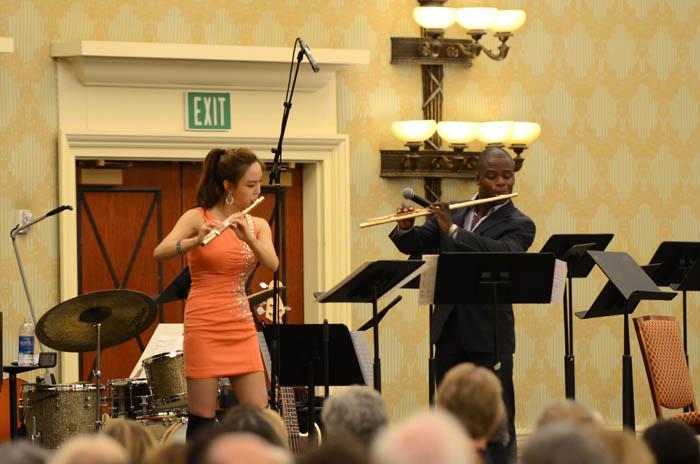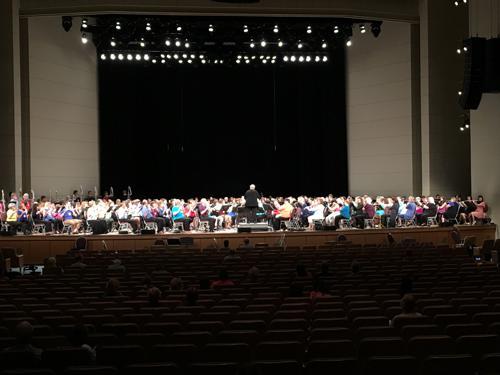The first image is the image on the left, the second image is the image on the right. Evaluate the accuracy of this statement regarding the images: "The left image shows at least one row of mostly women facing forward, dressed in black, and holding an instrument but not playing it.". Is it true? Answer yes or no. No. The first image is the image on the left, the second image is the image on the right. Assess this claim about the two images: "Several musicians in black pose for a picture with their instruments in one of the images.". Correct or not? Answer yes or no. No. 